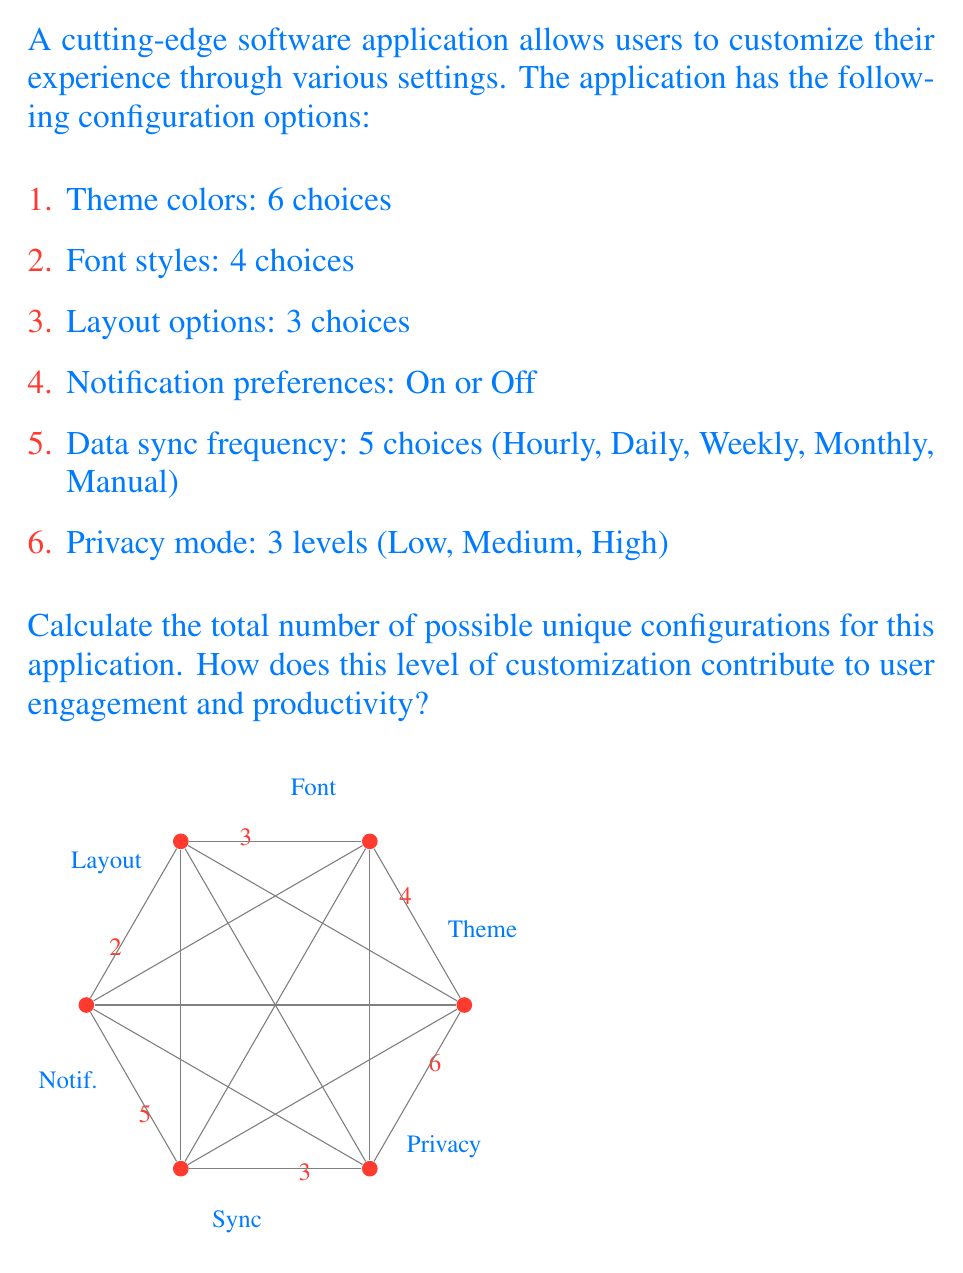Provide a solution to this math problem. To calculate the total number of possible unique configurations, we need to apply the multiplication principle of combinatorics. This principle states that if we have a sequence of independent choices, the total number of possible outcomes is the product of the number of choices for each decision.

Let's break down the calculation step by step:

1. Theme colors: 6 choices
2. Font styles: 4 choices
3. Layout options: 3 choices
4. Notification preferences: 2 choices (On or Off)
5. Data sync frequency: 5 choices
6. Privacy mode: 3 levels

The total number of configurations is the product of these choices:

$$\text{Total Configurations} = 6 \times 4 \times 3 \times 2 \times 5 \times 3$$

Let's calculate this step by step:

$$\begin{align}
\text{Total Configurations} &= 6 \times 4 \times 3 \times 2 \times 5 \times 3 \\
&= 24 \times 3 \times 2 \times 5 \times 3 \\
&= 72 \times 2 \times 5 \times 3 \\
&= 144 \times 5 \times 3 \\
&= 720 \times 3 \\
&= 2,160
\end{align}$$

Therefore, there are 2,160 possible unique configurations for this application.

This high level of customization can contribute to user engagement and productivity in several ways:

1. Personalization: Users can tailor the application to their specific preferences, potentially increasing their comfort and efficiency while using the software.

2. Adaptability: The application can be configured to suit various work environments and personal styles, making it versatile for different users and scenarios.

3. User control: Giving users control over their experience can lead to increased satisfaction and a sense of ownership, potentially boosting engagement.

4. Optimization: Users can experiment with different configurations to find the setup that maximizes their productivity.

5. Cognitive load reduction: By allowing users to customize the interface, they can create a familiar environment that reduces cognitive load and improves focus on tasks.

These factors align with the persona of a computer programmer who is skeptical of technology's negative effects on mental health, as the customization options empower users to create a digital environment that suits their individual needs and preferences.
Answer: 2,160 unique configurations 